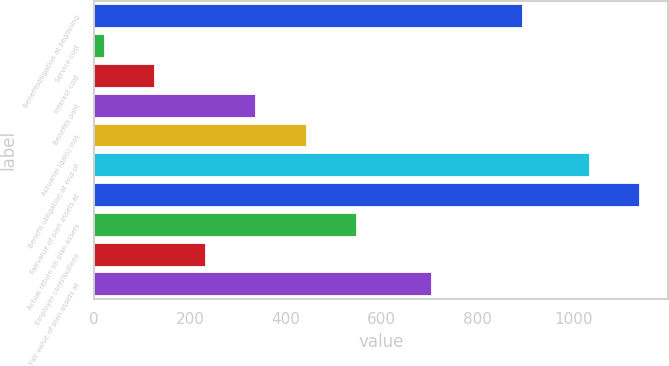Convert chart to OTSL. <chart><loc_0><loc_0><loc_500><loc_500><bar_chart><fcel>Benefitobligation at beginning<fcel>Service cost<fcel>Interest cost<fcel>Benefits paid<fcel>Actuarial (gain) loss<fcel>Benefit obligation at end of<fcel>Fairvalue of plan assets at<fcel>Actual return on plan assets<fcel>Employer contributions<fcel>Fair value of plan assets at<nl><fcel>896<fcel>23<fcel>128.1<fcel>338.3<fcel>443.4<fcel>1035<fcel>1140.1<fcel>548.5<fcel>233.2<fcel>705<nl></chart> 